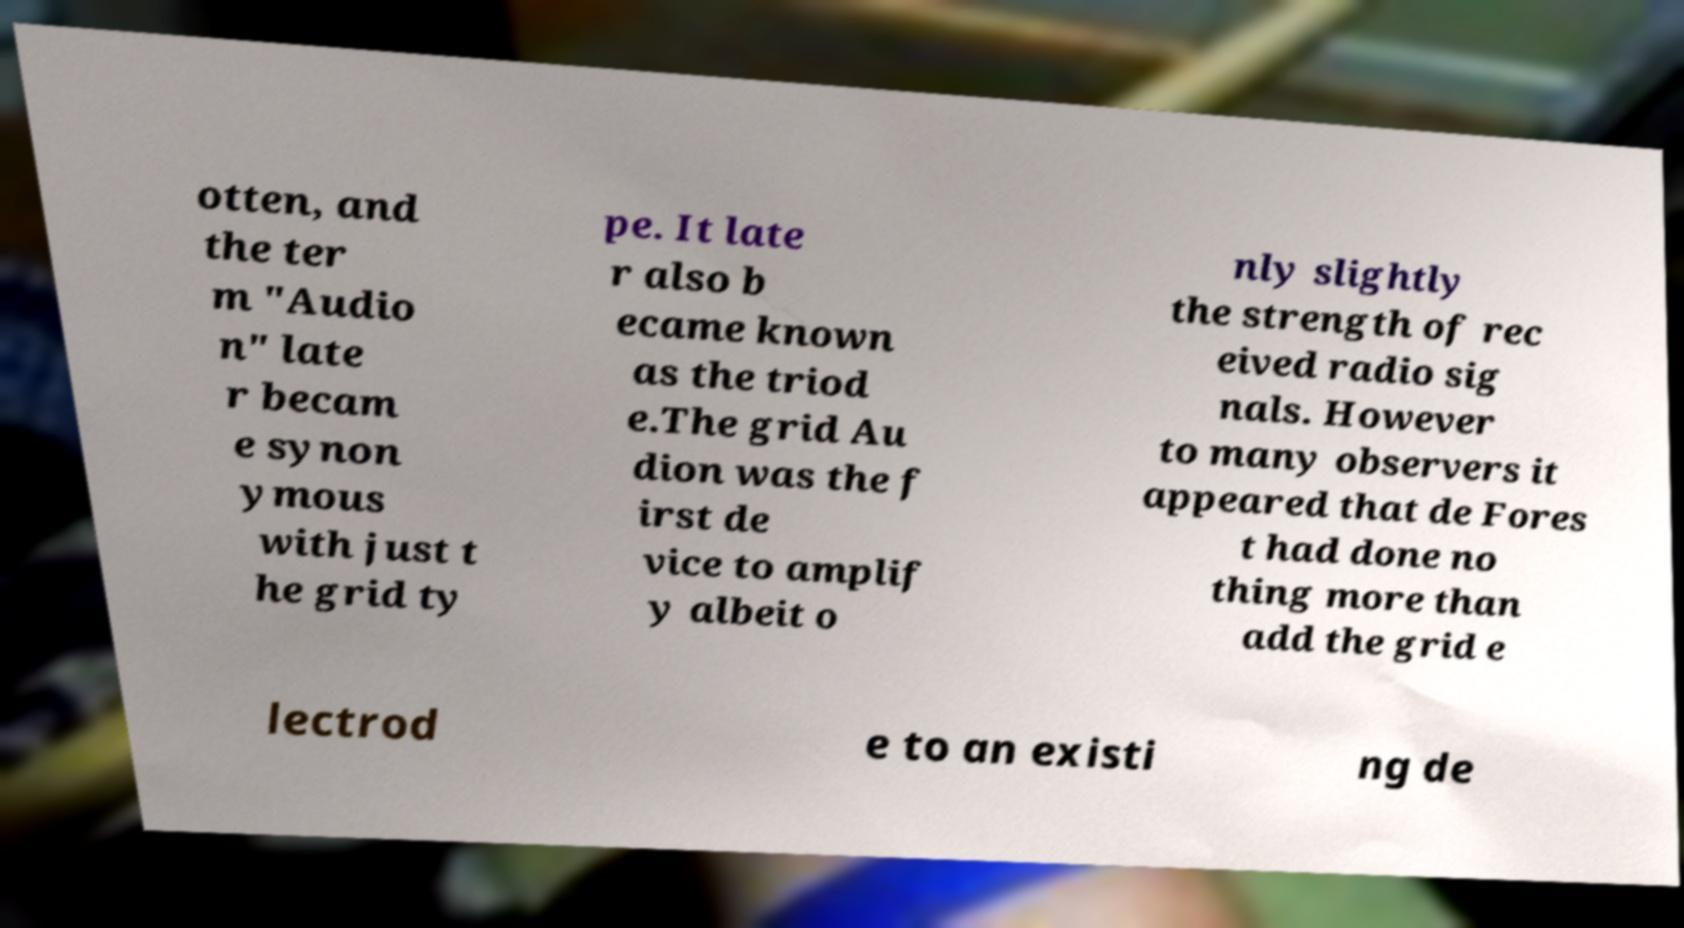What messages or text are displayed in this image? I need them in a readable, typed format. otten, and the ter m "Audio n" late r becam e synon ymous with just t he grid ty pe. It late r also b ecame known as the triod e.The grid Au dion was the f irst de vice to amplif y albeit o nly slightly the strength of rec eived radio sig nals. However to many observers it appeared that de Fores t had done no thing more than add the grid e lectrod e to an existi ng de 